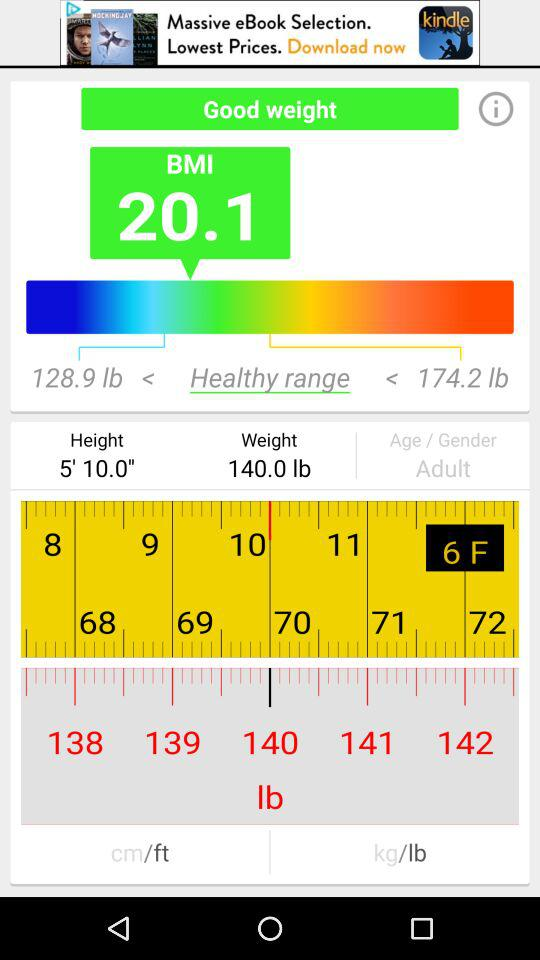What is the given height? The given height is 5' 10.0". 